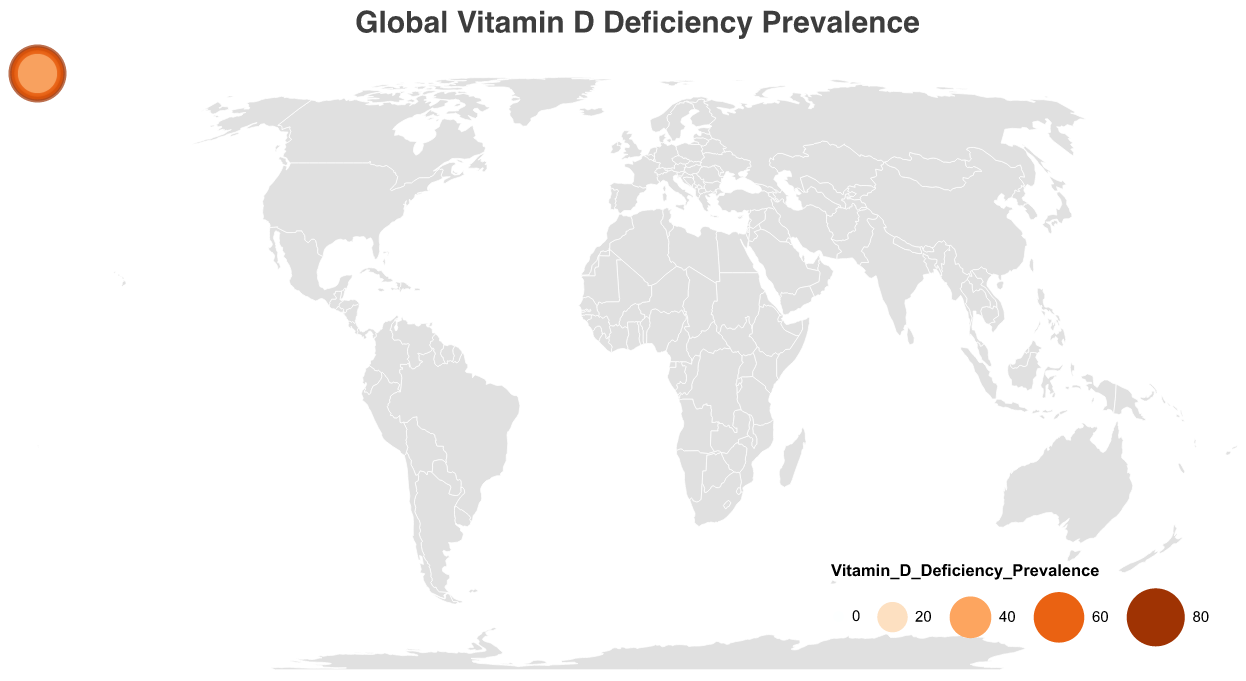Which region has the highest prevalence of vitamin D deficiency? By looking at the sizes and colors of the circles on the map, Nigeria in Africa shows the highest vitamin D deficiency prevalence at 80%
Answer: Nigeria Which country in the Middle East has higher vitamin D deficiency, Saudi Arabia or Turkey? Check the data points for both countries; Saudi Arabia has 60% and Turkey has 52%. Therefore, Saudi Arabia has a higher prevalence
Answer: Saudi Arabia How does the prevalence of vitamin D deficiency in Australia compare to Canada? Australia's prevalence is 23% while Canada's is higher at 32%. Thus, Canada has a higher prevalence than Australia
Answer: Canada Which continent shows the most variability in vitamin D deficiency prevalence among its countries represented in the data? Africa includes Nigeria at 80% and South Africa at 63%, indicating a large range, suggesting high variability within the continent
Answer: Africa How does the vitamin D deficiency prevalence in the United States compare to Brazil? The United States has a prevalence of 42% while Brazil has 40%. The United States has a slightly higher prevalence
Answer: United States What's the average vitamin D deficiency prevalence for the countries in North America? The prevalence rates for North America are: United States (42%), Canada (32%), and Mexico (38%). The average is calculated as (42+32+38)/3 = 37.3%
Answer: 37.3% Which East Asian country has a lower prevalence of vitamin D deficiency, China or Japan? Refer to the data, China is at 55% and Japan is at 50%. Therefore, Japan has a lower prevalence
Answer: Japan Which region in Europe has the lowest prevalence of vitamin D deficiency? Southern Europe (Italy at 35%) and Western Europe (United Kingdom at 30%) are the only two continents shown. Among them, Western Europe has the lower prevalence
Answer: Western Europe How much higher is the vitamin D deficiency prevalence in Nigeria compared to the United Kingdom? Nigeria has 80% while the United Kingdom has 30%. The difference is 80% - 30% = 50%
Answer: 50% Which country in the Southern Hemisphere has the highest prevalence of vitamin D deficiency? The Southern Hemisphere includes Brazil (40%), Australia (23%), and South Africa (63%). Among these, South Africa has the highest prevalence
Answer: South Africa 